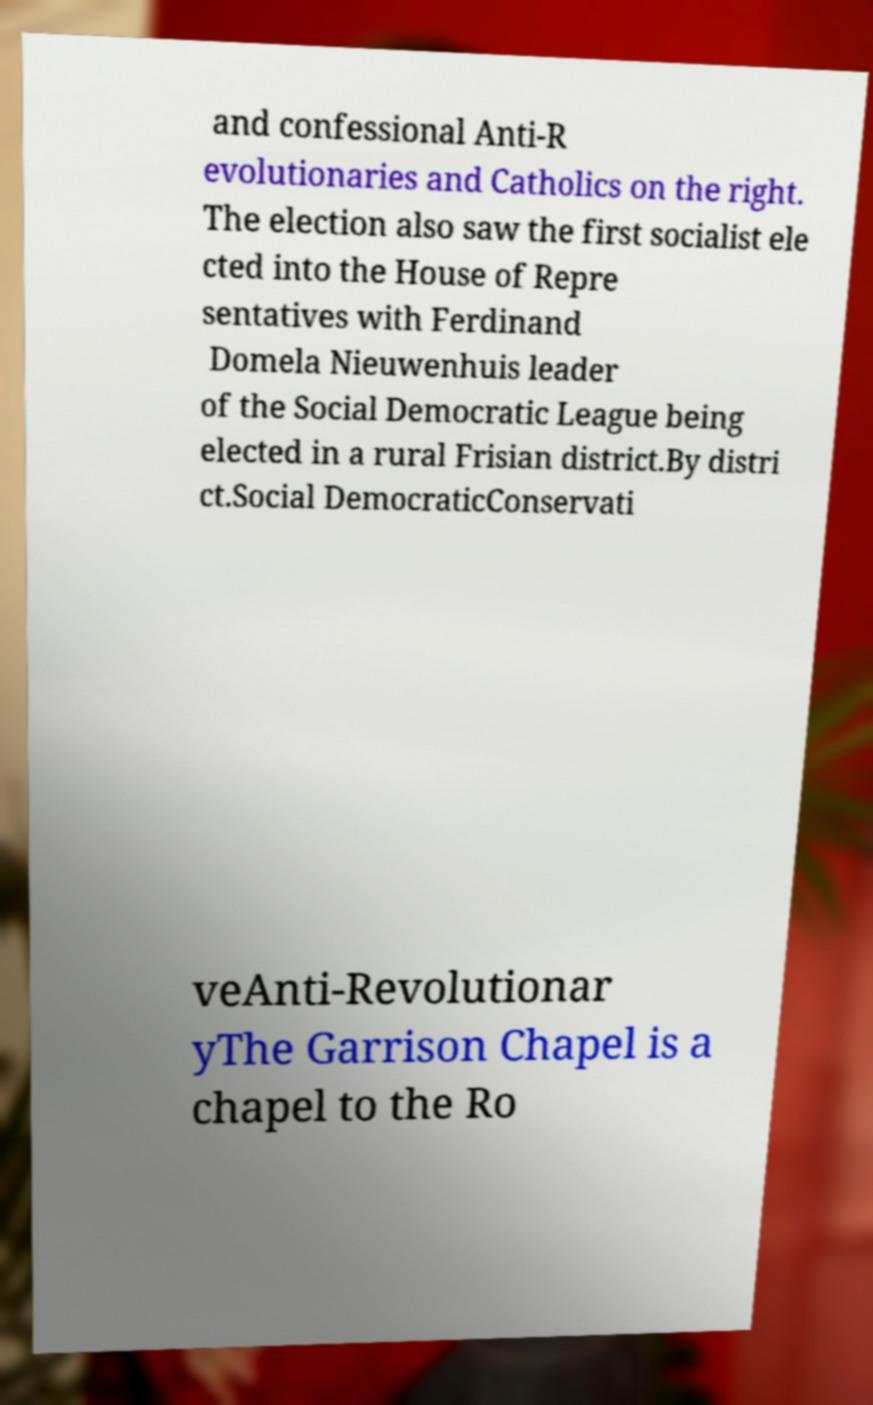I need the written content from this picture converted into text. Can you do that? and confessional Anti-R evolutionaries and Catholics on the right. The election also saw the first socialist ele cted into the House of Repre sentatives with Ferdinand Domela Nieuwenhuis leader of the Social Democratic League being elected in a rural Frisian district.By distri ct.Social DemocraticConservati veAnti-Revolutionar yThe Garrison Chapel is a chapel to the Ro 